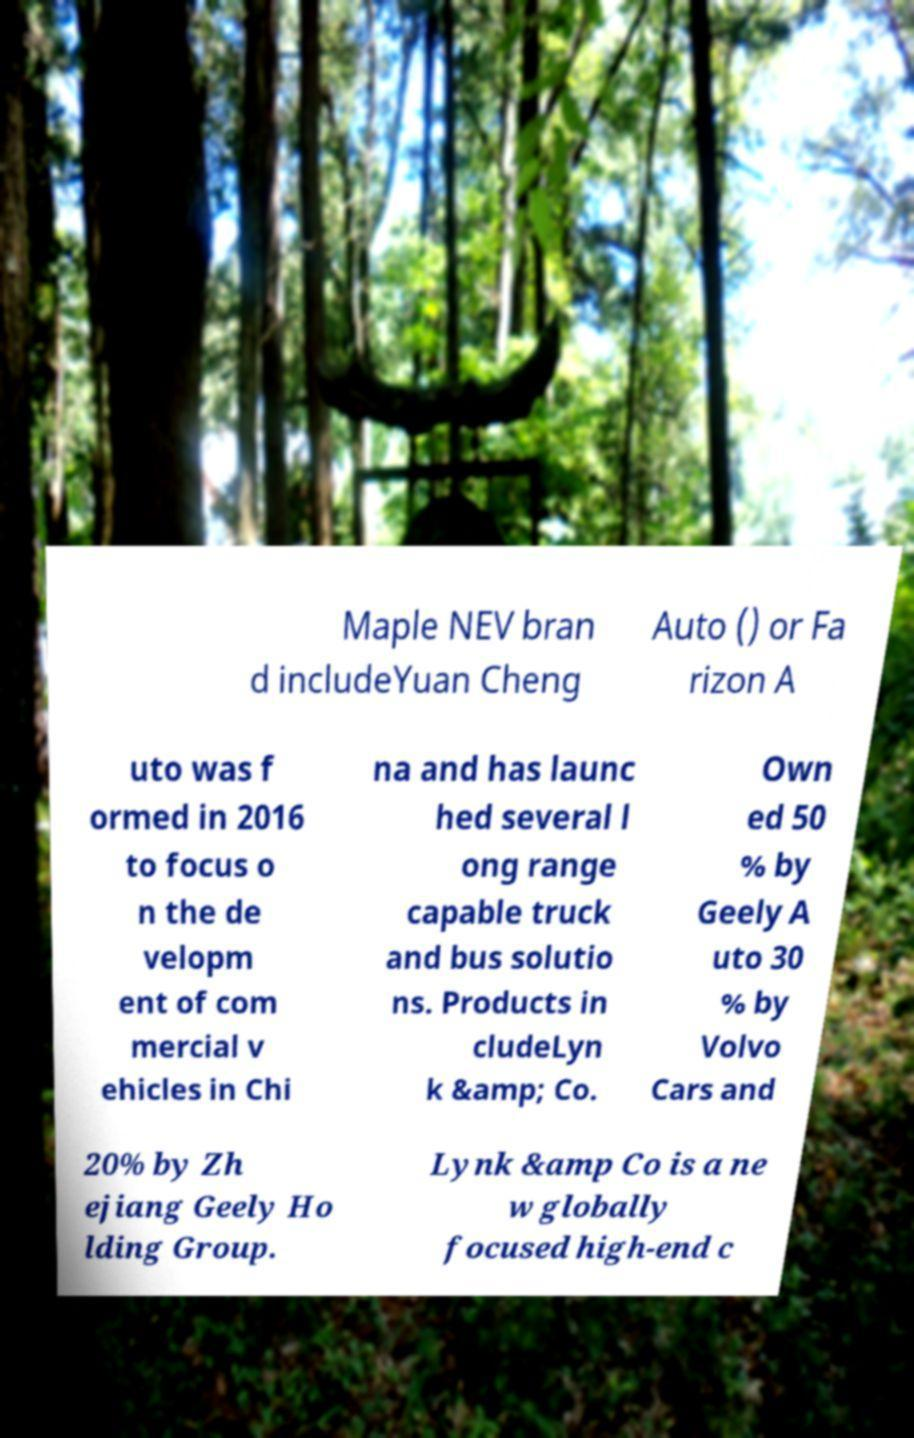Please read and relay the text visible in this image. What does it say? Maple NEV bran d includeYuan Cheng Auto () or Fa rizon A uto was f ormed in 2016 to focus o n the de velopm ent of com mercial v ehicles in Chi na and has launc hed several l ong range capable truck and bus solutio ns. Products in cludeLyn k &amp; Co. Own ed 50 % by Geely A uto 30 % by Volvo Cars and 20% by Zh ejiang Geely Ho lding Group. Lynk &amp Co is a ne w globally focused high-end c 